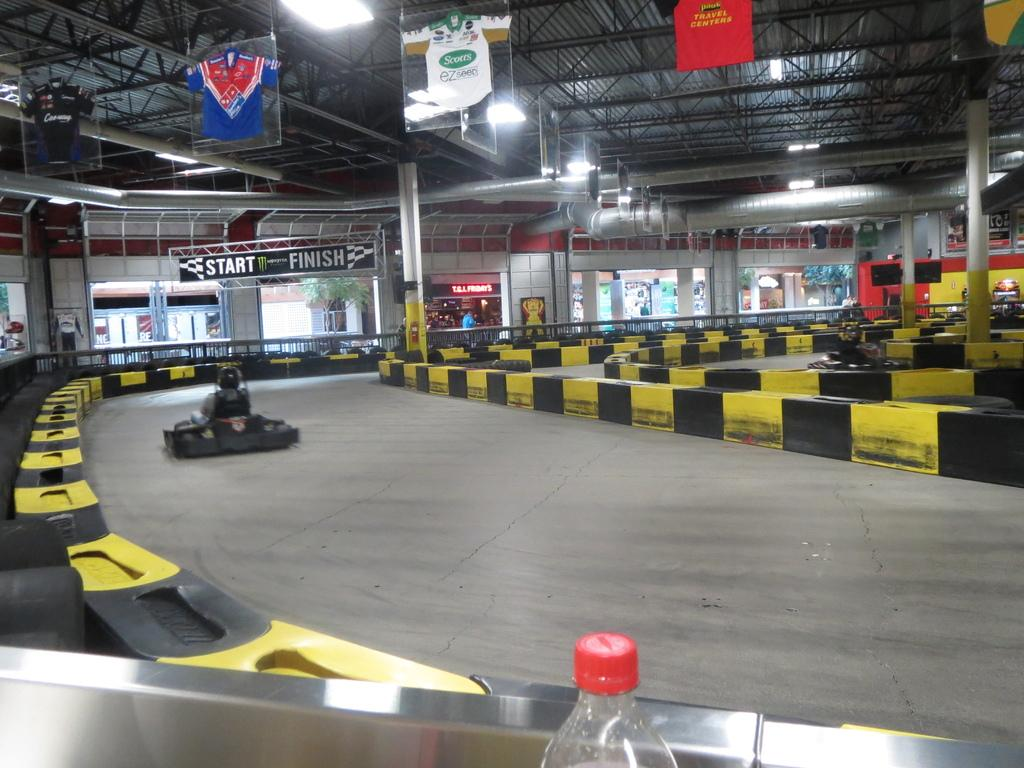What object can be seen in the image? There is a bottle in the image. What are the two persons in the image doing? They are on vehicles in the image. What can be seen in the background of the image? There are pillars, a plant, and banners in the background of the image. What type of crate is being used for the argument in the image? There is no crate or argument present in the image. What punishment is being given to the person in the image? There is no punishment being given to anyone in the image. 